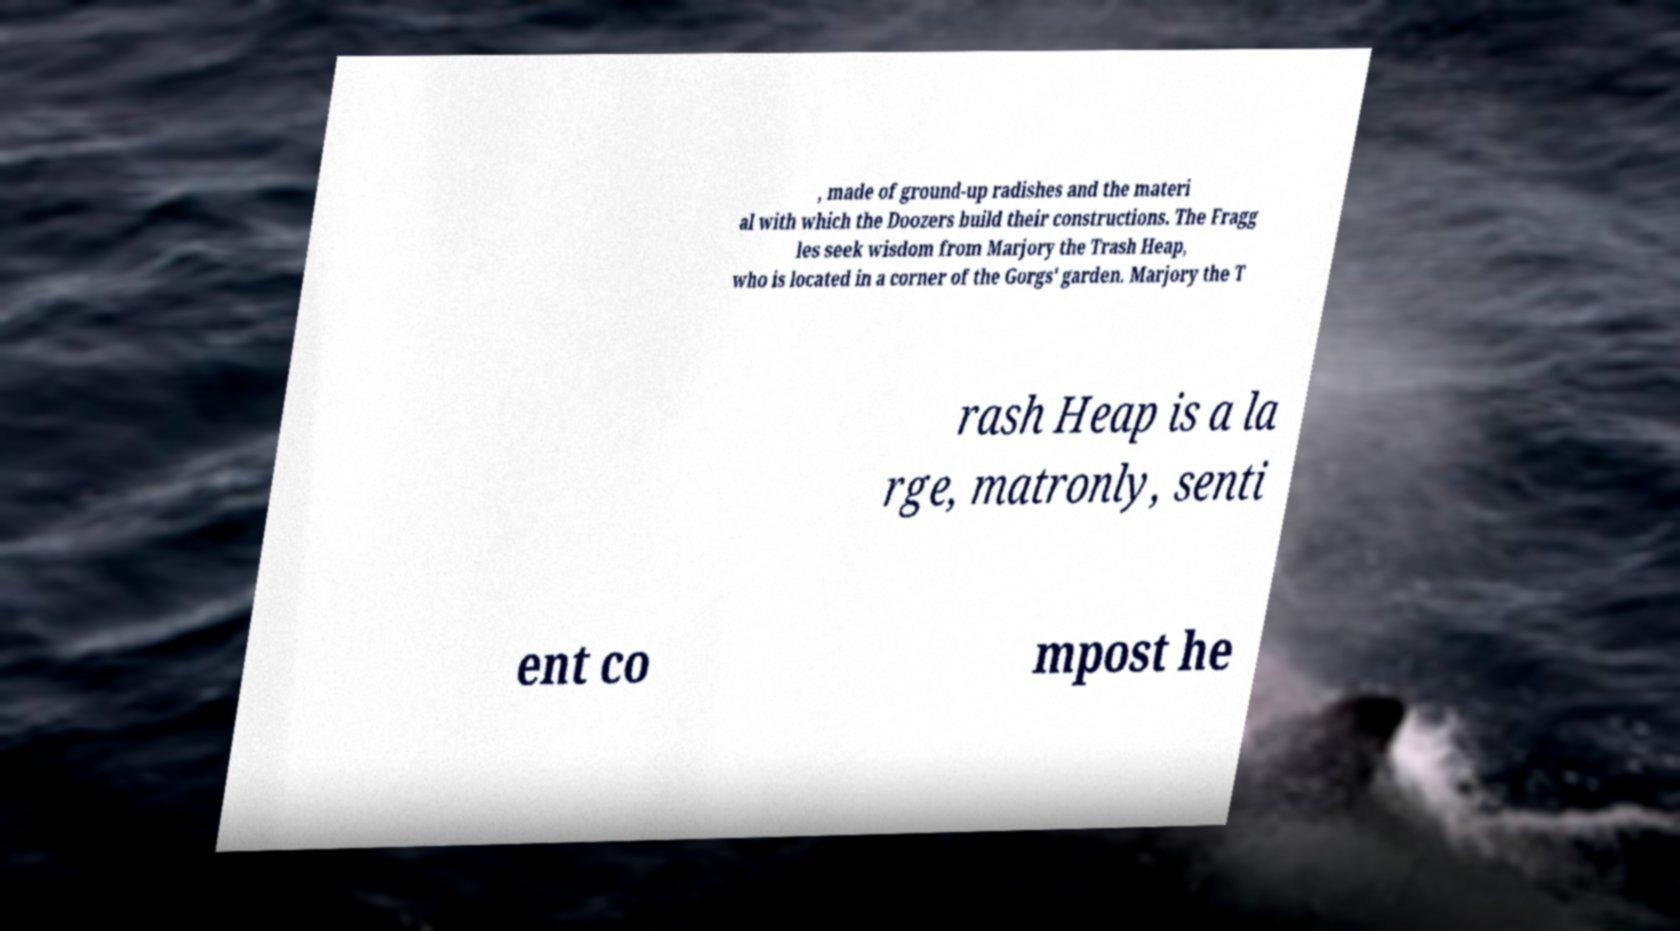Can you read and provide the text displayed in the image?This photo seems to have some interesting text. Can you extract and type it out for me? , made of ground-up radishes and the materi al with which the Doozers build their constructions. The Fragg les seek wisdom from Marjory the Trash Heap, who is located in a corner of the Gorgs' garden. Marjory the T rash Heap is a la rge, matronly, senti ent co mpost he 